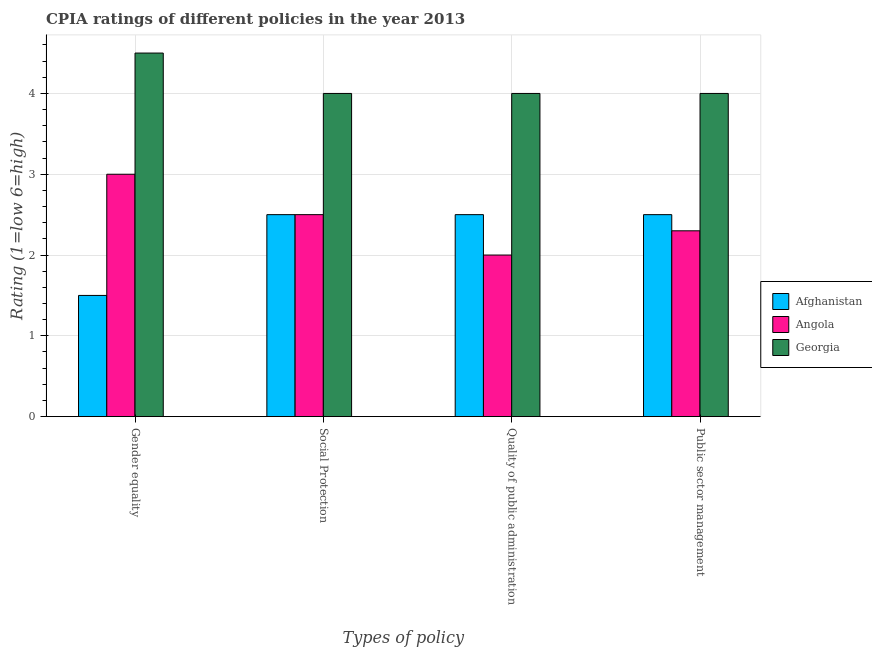How many different coloured bars are there?
Ensure brevity in your answer.  3. How many groups of bars are there?
Give a very brief answer. 4. Are the number of bars per tick equal to the number of legend labels?
Offer a very short reply. Yes. How many bars are there on the 3rd tick from the right?
Keep it short and to the point. 3. What is the label of the 3rd group of bars from the left?
Provide a short and direct response. Quality of public administration. What is the cpia rating of gender equality in Afghanistan?
Offer a very short reply. 1.5. Across all countries, what is the minimum cpia rating of gender equality?
Provide a succinct answer. 1.5. In which country was the cpia rating of quality of public administration maximum?
Ensure brevity in your answer.  Georgia. In which country was the cpia rating of gender equality minimum?
Give a very brief answer. Afghanistan. What is the difference between the cpia rating of gender equality in Angola and the cpia rating of public sector management in Georgia?
Your answer should be compact. -1. What is the average cpia rating of public sector management per country?
Offer a terse response. 2.93. In how many countries, is the cpia rating of gender equality greater than 2 ?
Your response must be concise. 2. What is the ratio of the cpia rating of gender equality in Afghanistan to that in Angola?
Give a very brief answer. 0.5. Is the difference between the cpia rating of gender equality in Afghanistan and Georgia greater than the difference between the cpia rating of social protection in Afghanistan and Georgia?
Offer a terse response. No. What is the difference between the highest and the lowest cpia rating of social protection?
Your response must be concise. 1.5. In how many countries, is the cpia rating of quality of public administration greater than the average cpia rating of quality of public administration taken over all countries?
Ensure brevity in your answer.  1. Is it the case that in every country, the sum of the cpia rating of public sector management and cpia rating of gender equality is greater than the sum of cpia rating of quality of public administration and cpia rating of social protection?
Provide a succinct answer. No. What does the 2nd bar from the left in Gender equality represents?
Offer a very short reply. Angola. What does the 3rd bar from the right in Public sector management represents?
Your response must be concise. Afghanistan. How many bars are there?
Offer a very short reply. 12. Are all the bars in the graph horizontal?
Provide a short and direct response. No. What is the difference between two consecutive major ticks on the Y-axis?
Provide a short and direct response. 1. Are the values on the major ticks of Y-axis written in scientific E-notation?
Make the answer very short. No. Does the graph contain any zero values?
Provide a short and direct response. No. Does the graph contain grids?
Provide a short and direct response. Yes. How many legend labels are there?
Ensure brevity in your answer.  3. What is the title of the graph?
Your answer should be very brief. CPIA ratings of different policies in the year 2013. Does "Qatar" appear as one of the legend labels in the graph?
Your answer should be compact. No. What is the label or title of the X-axis?
Ensure brevity in your answer.  Types of policy. What is the Rating (1=low 6=high) in Afghanistan in Gender equality?
Provide a short and direct response. 1.5. What is the Rating (1=low 6=high) in Georgia in Gender equality?
Provide a succinct answer. 4.5. What is the Rating (1=low 6=high) of Afghanistan in Social Protection?
Your answer should be compact. 2.5. What is the Rating (1=low 6=high) of Angola in Social Protection?
Your answer should be very brief. 2.5. What is the Rating (1=low 6=high) of Georgia in Social Protection?
Provide a short and direct response. 4. What is the Rating (1=low 6=high) of Afghanistan in Public sector management?
Your answer should be very brief. 2.5. What is the Rating (1=low 6=high) of Angola in Public sector management?
Ensure brevity in your answer.  2.3. What is the Rating (1=low 6=high) of Georgia in Public sector management?
Your answer should be very brief. 4. Across all Types of policy, what is the maximum Rating (1=low 6=high) in Georgia?
Keep it short and to the point. 4.5. Across all Types of policy, what is the minimum Rating (1=low 6=high) in Afghanistan?
Your response must be concise. 1.5. What is the total Rating (1=low 6=high) of Georgia in the graph?
Ensure brevity in your answer.  16.5. What is the difference between the Rating (1=low 6=high) in Georgia in Gender equality and that in Social Protection?
Your answer should be very brief. 0.5. What is the difference between the Rating (1=low 6=high) of Afghanistan in Gender equality and that in Quality of public administration?
Give a very brief answer. -1. What is the difference between the Rating (1=low 6=high) in Afghanistan in Gender equality and that in Public sector management?
Make the answer very short. -1. What is the difference between the Rating (1=low 6=high) of Georgia in Gender equality and that in Public sector management?
Your answer should be very brief. 0.5. What is the difference between the Rating (1=low 6=high) of Afghanistan in Social Protection and that in Quality of public administration?
Provide a short and direct response. 0. What is the difference between the Rating (1=low 6=high) of Afghanistan in Social Protection and that in Public sector management?
Your response must be concise. 0. What is the difference between the Rating (1=low 6=high) in Angola in Social Protection and that in Public sector management?
Your answer should be very brief. 0.2. What is the difference between the Rating (1=low 6=high) in Georgia in Social Protection and that in Public sector management?
Your response must be concise. 0. What is the difference between the Rating (1=low 6=high) in Afghanistan in Gender equality and the Rating (1=low 6=high) in Angola in Social Protection?
Make the answer very short. -1. What is the difference between the Rating (1=low 6=high) of Angola in Gender equality and the Rating (1=low 6=high) of Georgia in Social Protection?
Provide a succinct answer. -1. What is the difference between the Rating (1=low 6=high) of Afghanistan in Gender equality and the Rating (1=low 6=high) of Angola in Quality of public administration?
Your answer should be very brief. -0.5. What is the difference between the Rating (1=low 6=high) in Angola in Gender equality and the Rating (1=low 6=high) in Georgia in Quality of public administration?
Offer a terse response. -1. What is the difference between the Rating (1=low 6=high) in Afghanistan in Gender equality and the Rating (1=low 6=high) in Angola in Public sector management?
Provide a succinct answer. -0.8. What is the difference between the Rating (1=low 6=high) in Afghanistan in Social Protection and the Rating (1=low 6=high) in Angola in Quality of public administration?
Provide a succinct answer. 0.5. What is the difference between the Rating (1=low 6=high) in Angola in Social Protection and the Rating (1=low 6=high) in Georgia in Quality of public administration?
Make the answer very short. -1.5. What is the difference between the Rating (1=low 6=high) in Afghanistan in Social Protection and the Rating (1=low 6=high) in Georgia in Public sector management?
Make the answer very short. -1.5. What is the difference between the Rating (1=low 6=high) in Angola in Social Protection and the Rating (1=low 6=high) in Georgia in Public sector management?
Offer a terse response. -1.5. What is the average Rating (1=low 6=high) in Afghanistan per Types of policy?
Offer a very short reply. 2.25. What is the average Rating (1=low 6=high) of Angola per Types of policy?
Offer a very short reply. 2.45. What is the average Rating (1=low 6=high) of Georgia per Types of policy?
Offer a terse response. 4.12. What is the difference between the Rating (1=low 6=high) in Afghanistan and Rating (1=low 6=high) in Angola in Gender equality?
Your answer should be compact. -1.5. What is the difference between the Rating (1=low 6=high) in Afghanistan and Rating (1=low 6=high) in Georgia in Gender equality?
Your answer should be compact. -3. What is the difference between the Rating (1=low 6=high) in Angola and Rating (1=low 6=high) in Georgia in Social Protection?
Your answer should be very brief. -1.5. What is the difference between the Rating (1=low 6=high) of Afghanistan and Rating (1=low 6=high) of Angola in Quality of public administration?
Your answer should be compact. 0.5. What is the difference between the Rating (1=low 6=high) of Afghanistan and Rating (1=low 6=high) of Georgia in Quality of public administration?
Keep it short and to the point. -1.5. What is the ratio of the Rating (1=low 6=high) in Georgia in Gender equality to that in Social Protection?
Provide a short and direct response. 1.12. What is the ratio of the Rating (1=low 6=high) in Afghanistan in Gender equality to that in Quality of public administration?
Ensure brevity in your answer.  0.6. What is the ratio of the Rating (1=low 6=high) in Angola in Gender equality to that in Public sector management?
Provide a succinct answer. 1.3. What is the ratio of the Rating (1=low 6=high) of Angola in Social Protection to that in Public sector management?
Offer a very short reply. 1.09. What is the ratio of the Rating (1=low 6=high) of Angola in Quality of public administration to that in Public sector management?
Your answer should be very brief. 0.87. What is the difference between the highest and the second highest Rating (1=low 6=high) in Afghanistan?
Keep it short and to the point. 0. What is the difference between the highest and the second highest Rating (1=low 6=high) in Angola?
Provide a succinct answer. 0.5. What is the difference between the highest and the lowest Rating (1=low 6=high) of Angola?
Offer a terse response. 1. 